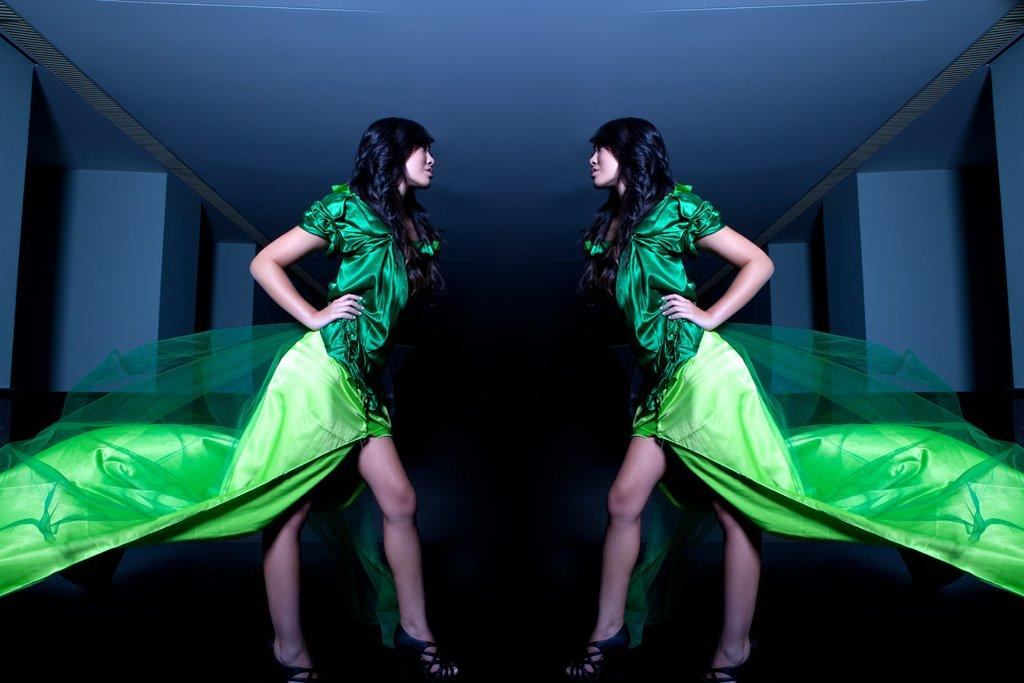Where was the image taken? The image was taken inside a hall. What can be seen in the center of the image? There are two persons in the center of the image. What are the persons wearing? The persons are wearing green color dresses. What are the persons doing in the image? The persons are standing. What can be seen in the background of the image? There is a roof and pillars visible in the background of the image. What type of gold jewelry can be seen on the persons in the image? There is no gold jewelry visible on the persons in the image; they are wearing green color dresses. Can you tell me which channel the persons are watching in the image? There is no television or channel visible in the image; it was taken inside a hall with two standing persons. 